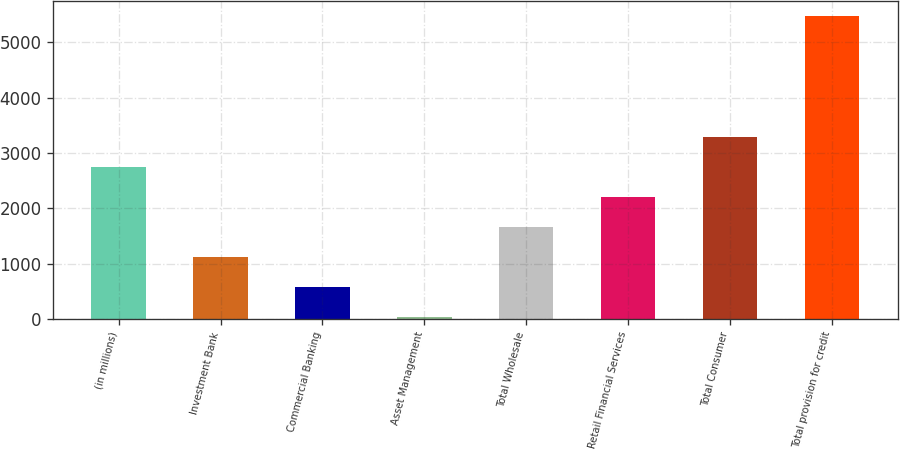Convert chart. <chart><loc_0><loc_0><loc_500><loc_500><bar_chart><fcel>(in millions)<fcel>Investment Bank<fcel>Commercial Banking<fcel>Asset Management<fcel>Total Wholesale<fcel>Retail Financial Services<fcel>Total Consumer<fcel>Total provision for credit<nl><fcel>2754<fcel>1118.4<fcel>573.2<fcel>28<fcel>1663.6<fcel>2208.8<fcel>3299.2<fcel>5480<nl></chart> 